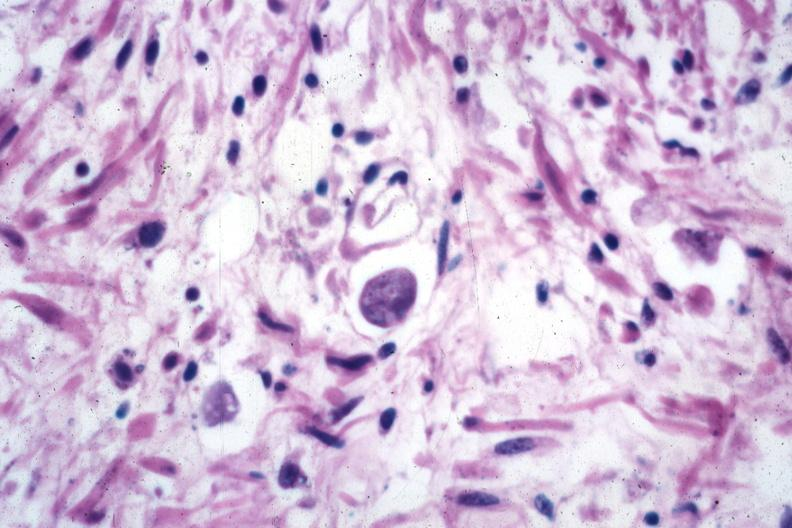s metastatic carcinoma prostate present?
Answer the question using a single word or phrase. No 